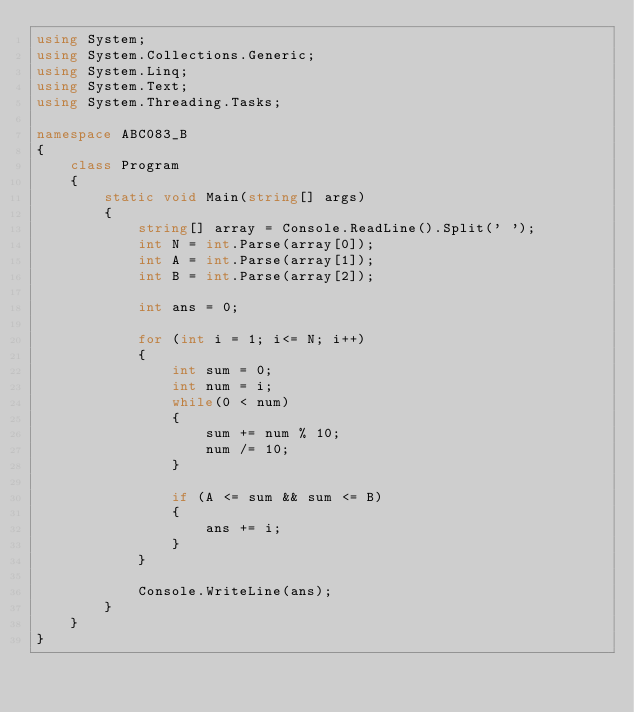Convert code to text. <code><loc_0><loc_0><loc_500><loc_500><_C#_>using System;
using System.Collections.Generic;
using System.Linq;
using System.Text;
using System.Threading.Tasks;

namespace ABC083_B
{
    class Program
    {
        static void Main(string[] args)
        {
            string[] array = Console.ReadLine().Split(' ');
            int N = int.Parse(array[0]);
            int A = int.Parse(array[1]);
            int B = int.Parse(array[2]);

            int ans = 0;

            for (int i = 1; i<= N; i++)
            {
                int sum = 0;
                int num = i;
                while(0 < num)
                {
                    sum += num % 10;
                    num /= 10;
                }

                if (A <= sum && sum <= B)
                {
                    ans += i;
                }
            }

            Console.WriteLine(ans);
        }
    }
}
</code> 